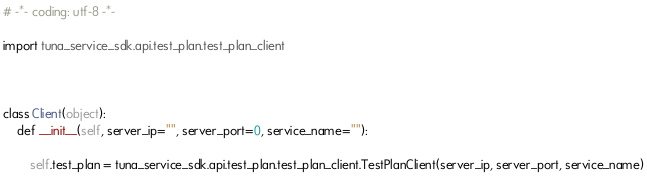<code> <loc_0><loc_0><loc_500><loc_500><_Python_># -*- coding: utf-8 -*-

import tuna_service_sdk.api.test_plan.test_plan_client



class Client(object):
    def __init__(self, server_ip="", server_port=0, service_name=""):
        
        self.test_plan = tuna_service_sdk.api.test_plan.test_plan_client.TestPlanClient(server_ip, server_port, service_name)
        
</code> 